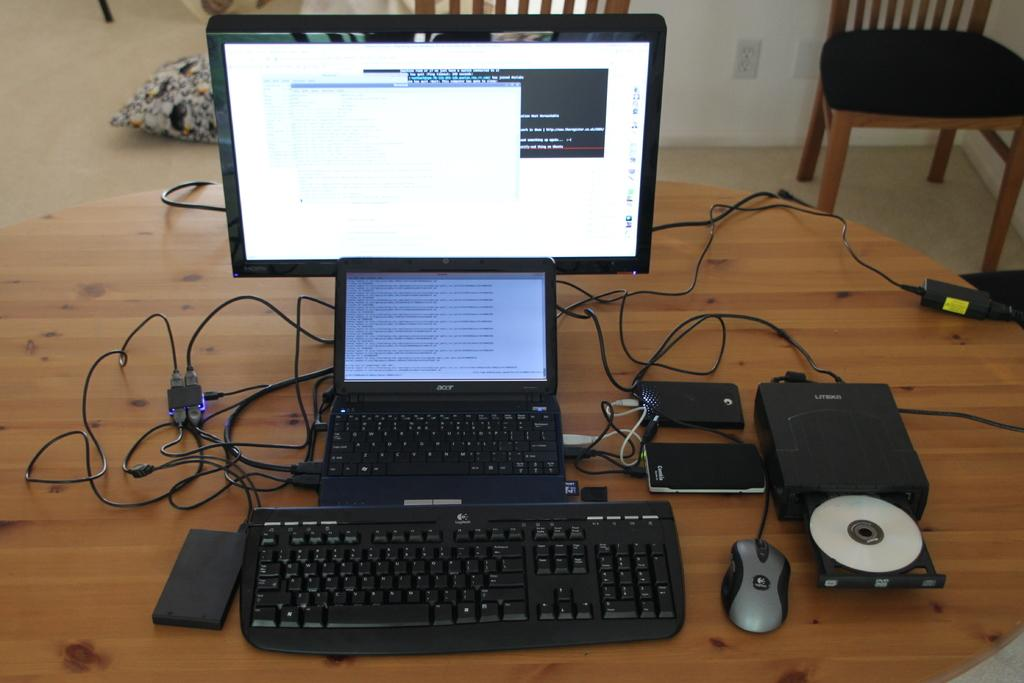What is the main object in the middle of the image? There is a table in the middle of the image. What electronic devices are on the table? A keyboard, a mouse, mobiles, a laptop, and a monitor are on the table. Are there any wires visible on the table? Yes, wires are visible on the table. What can be seen in the background of the image? There are chairs, a pillow, and a wall in the background. What is visible on the floor in the image? The floor is visible in the image. What type of steam is coming from the laptop in the image? There is no steam coming from the laptop in the image. What kind of breakfast is being served on the table in the image? There is no breakfast present in the image; it features a table with electronic devices and wires. 